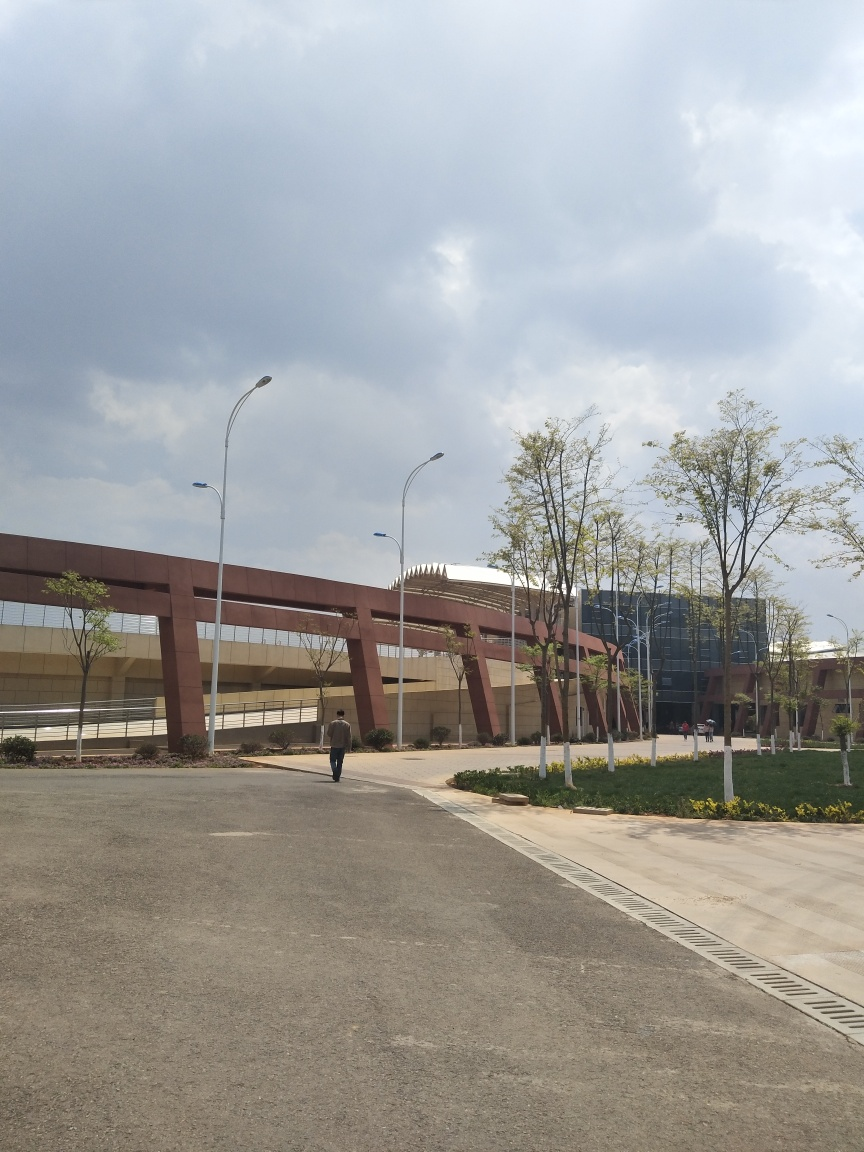Are there any quality issues with this image? The image appears to be slightly overexposed, and there is a lack of sharpness overall, which suggests that the focus isn't as crisp as it could be. The composition could be improved by following the rule of thirds. However, the image is decently composed with clear subject matter. 